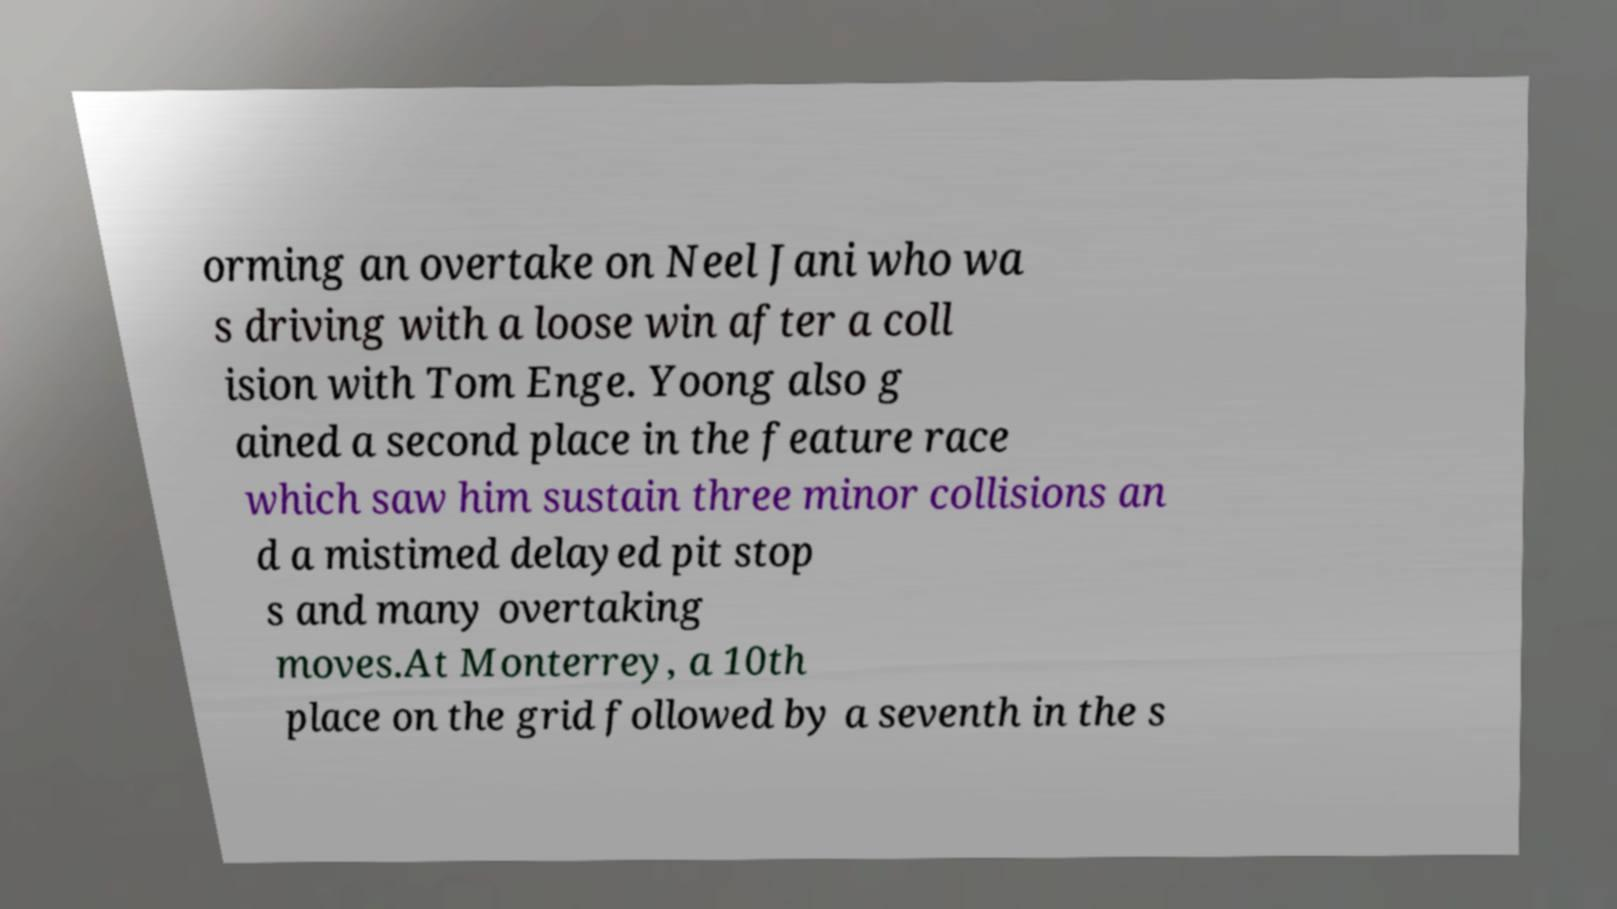Could you assist in decoding the text presented in this image and type it out clearly? orming an overtake on Neel Jani who wa s driving with a loose win after a coll ision with Tom Enge. Yoong also g ained a second place in the feature race which saw him sustain three minor collisions an d a mistimed delayed pit stop s and many overtaking moves.At Monterrey, a 10th place on the grid followed by a seventh in the s 